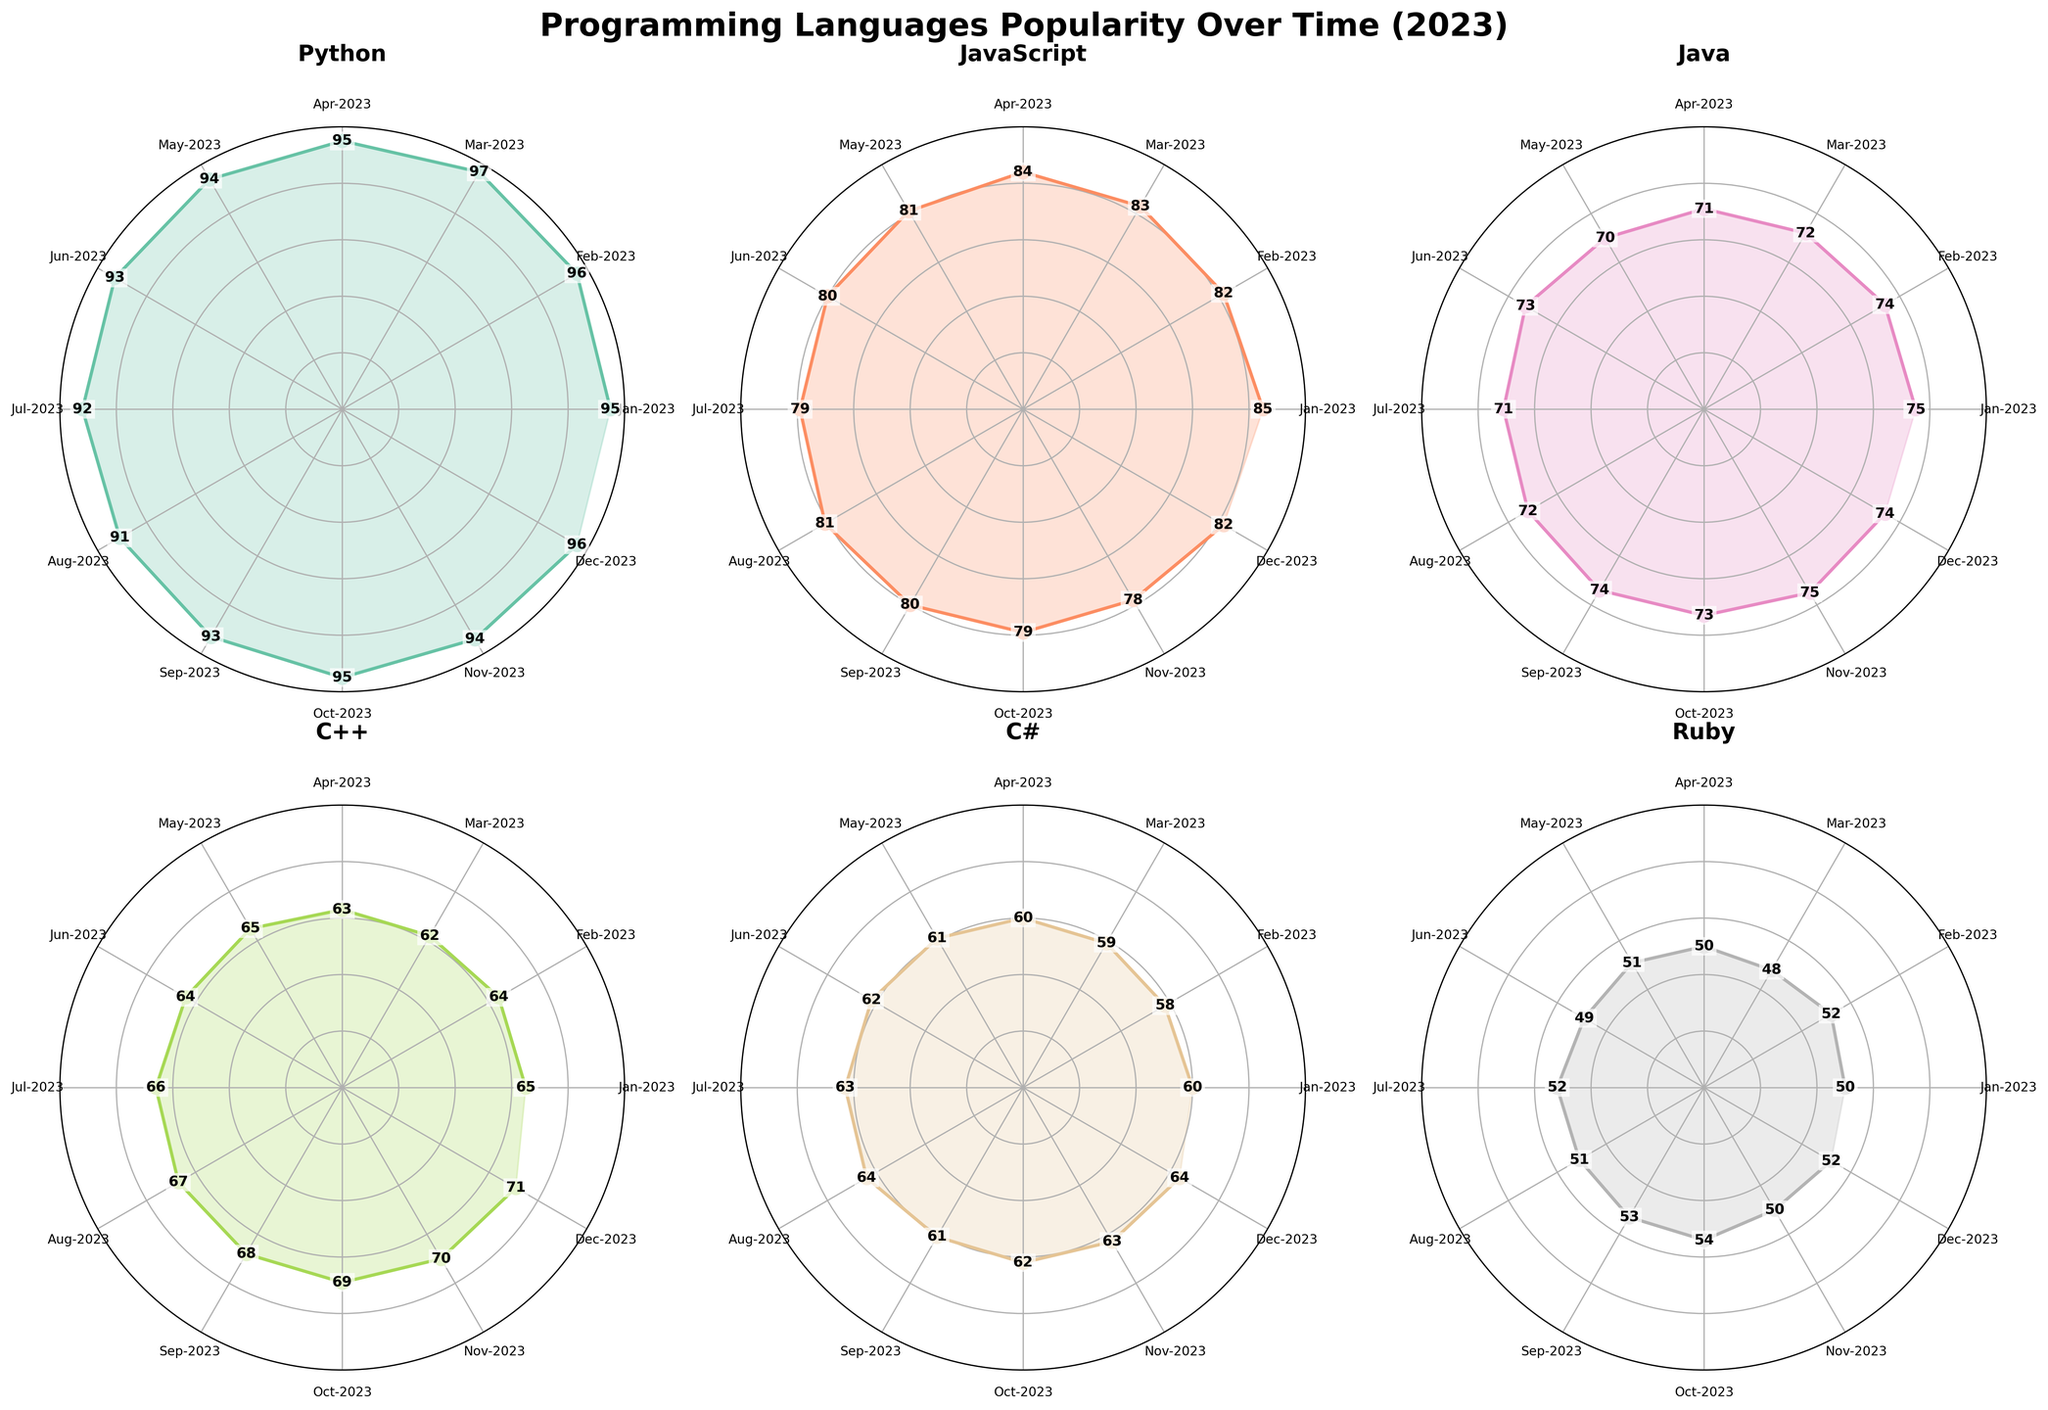what is the title of the entire figure? The main title of the entire figure is usually positioned at the top center. In this case, it is easy to spot the text at the center: "Programming Languages Popularity Over Time (2023)"
Answer: "Programming Languages Popularity Over Time (2023)" How many languages are represented in the subplots? By looking at the individual subplots, we can count the titles to determine the number of languages represented. The titles are "Python," "JavaScript," "Java," "C++," "C#," and "Ruby." So, there are 6 languages in total.
Answer: 6 Which language had the highest popularity in July-2023? For the month of July-2023, we go through each subplot and corresponding data points. Python has the highest data point labeled "92" in July-2023 compared to other languages.
Answer: Python What were the popularity scores for C++ in Jan-2023 and Dec-2023? By observing the C++ subplot, look at the radial points for "Jan-2023" and "Dec-2023". These points are labeled with values, "65" for Jan-2023 and "71" for Dec-2023.
Answer: 65, 71 Which language showed the largest decrease in popularity from Jan-2023 to Dec-2023? By calculating the difference in values for each language between Jan-2023 and Dec-2023:
Python: 95 - 96 = -1,
JavaScript: 85 - 82 = 3,
Java: 75 - 74 = 1,
C++: 65 - 71 = -6,
C#: 60 - 64 = -4,
Ruby: 50 - 52 = -2.
C++ had the largest decrease of 6 points.
Answer: C++ Comparing Python and JavaScript, which language had the greater popularity growth from Feb-2023 to Sep-2023? First, find the values for Python: Feb-2023 is 96 and Sep-2023 is 93. Change = 93 - 96 = -3. Then JavaScript: Feb-2023 is 82 and Sep-2023 is 80. Change = 80 - 82 = -2. JavaScript had a smaller decrease, indicating greater growth compared to Python.
Answer: JavaScript What is the average popularity score of Ruby throughout the year 2023? The popularity values for Ruby each month are: 50, 52, 48, 50, 51, 49, 52, 51, 53, 54, 50, 52. Sum these values: 50 + 52 + 48 + 50 + 51 + 49 + 52 + 51 + 53 + 54 + 50 + 52 = 612. Average is 612 / 12 = 51.
Answer: 51 Which month shows the highest cumulative popularity for all programming languages? Sum the values for each month: Jan-2023: 95 + 85 + 75 + 65 + 60 + 50 = 430,
Feb-2023: 96 + 82 + 74 + 64 + 58 + 52 = 426,
Mar-2023: 97 + 83 + 72 + 62 + 59 + 48 = 421,
Apr-2023: 95 + 84 + 71 + 63 + 60 + 50 = 423,
May-2023: 94 + 81 + 70 + 65 + 61 + 51 = 422,
Jun-2023: 93 + 80 + 73 + 64 + 62 + 49 = 421,
Jul-2023: 92 + 79 + 71 + 66 + 63 + 52 = 423,
Aug-2023: 91 + 81 + 72 + 67 + 64 + 51 = 426,
Sep-2023: 93 + 80 + 74 + 68 + 61 + 53 = 429,
Oct-2023: 95 + 79 + 73 + 69 + 62 + 54 = 432,
Nov-2023: 94 + 78 + 75 + 70 + 63 + 50 = 430,
Dec-2023: 96 + 82 + 74 + 71 + 64 + 52 = 439. 
Oct-2023 shows the highest cumulative popularity with a total of 432.
Answer: Oct-2023 